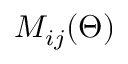<formula> <loc_0><loc_0><loc_500><loc_500>M _ { i j } ( \Theta )</formula> 